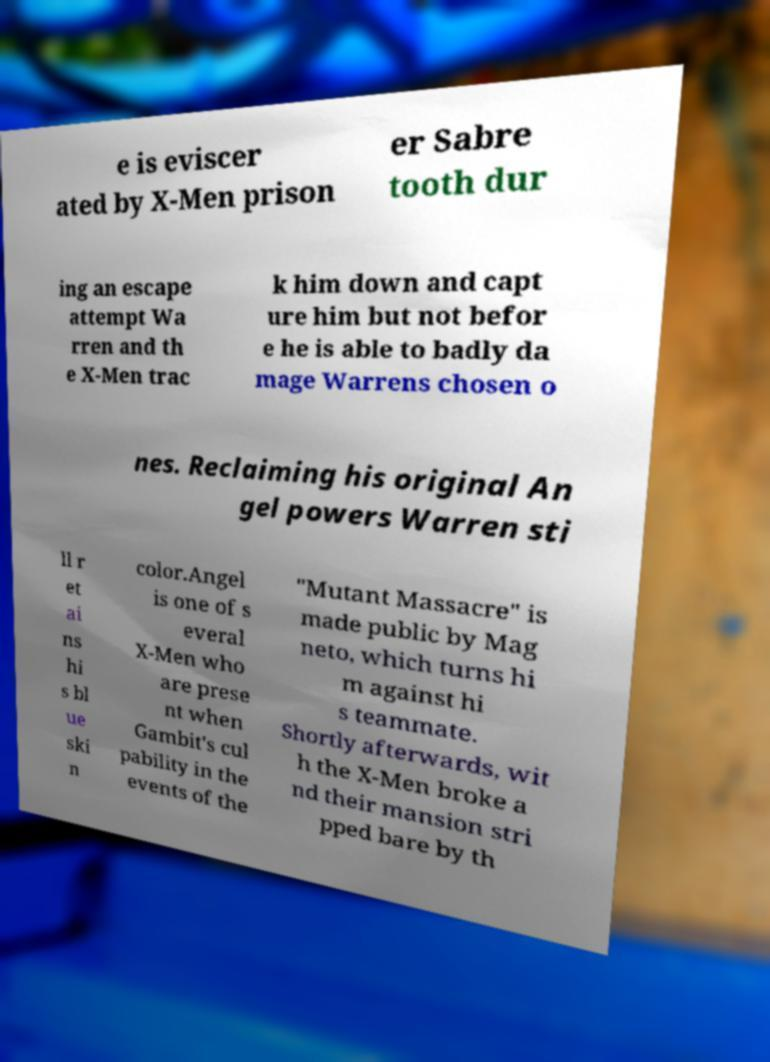Please read and relay the text visible in this image. What does it say? e is eviscer ated by X-Men prison er Sabre tooth dur ing an escape attempt Wa rren and th e X-Men trac k him down and capt ure him but not befor e he is able to badly da mage Warrens chosen o nes. Reclaiming his original An gel powers Warren sti ll r et ai ns hi s bl ue ski n color.Angel is one of s everal X-Men who are prese nt when Gambit's cul pability in the events of the "Mutant Massacre" is made public by Mag neto, which turns hi m against hi s teammate. Shortly afterwards, wit h the X-Men broke a nd their mansion stri pped bare by th 